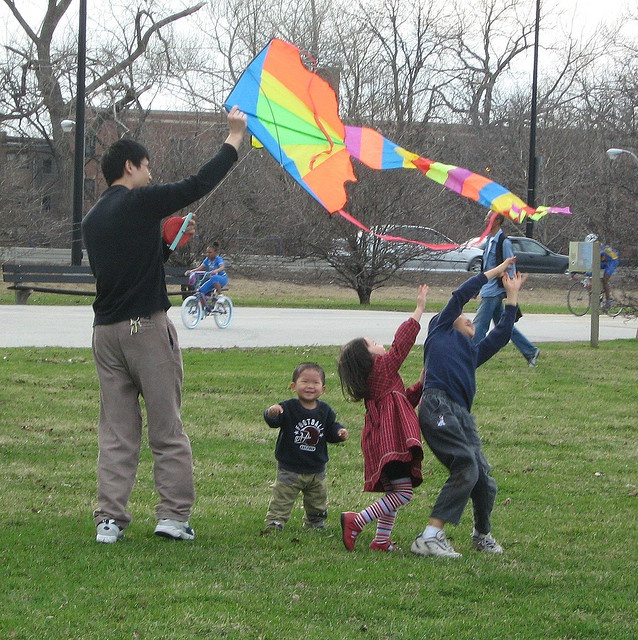Describe the objects in this image and their specific colors. I can see people in white, gray, black, maroon, and darkgray tones, kite in white, salmon, lightblue, khaki, and lightgreen tones, people in white, black, navy, gray, and darkblue tones, people in white, black, gray, and darkgreen tones, and car in white, gray, darkgray, black, and lightgray tones in this image. 